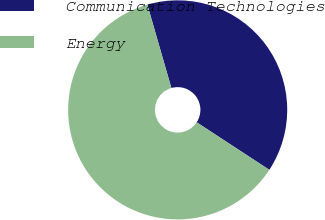<chart> <loc_0><loc_0><loc_500><loc_500><pie_chart><fcel>Communication Technologies<fcel>Energy<nl><fcel>38.69%<fcel>61.31%<nl></chart> 